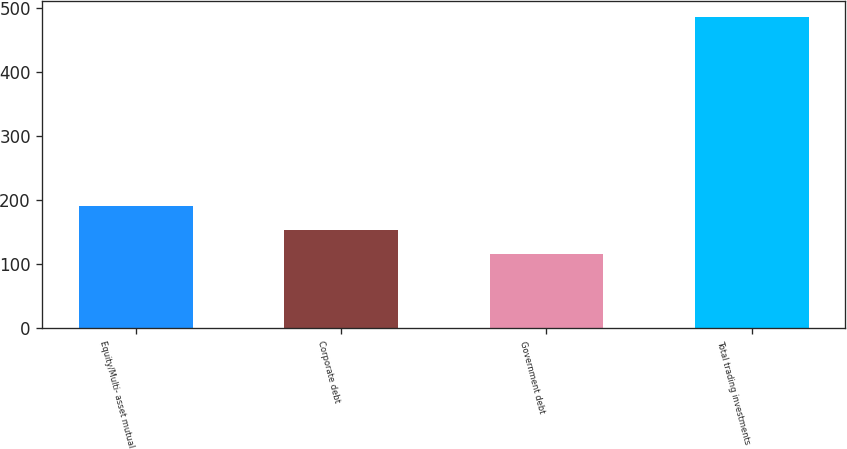Convert chart to OTSL. <chart><loc_0><loc_0><loc_500><loc_500><bar_chart><fcel>Equity/Multi- asset mutual<fcel>Corporate debt<fcel>Government debt<fcel>Total trading investments<nl><fcel>190<fcel>153<fcel>116<fcel>486<nl></chart> 